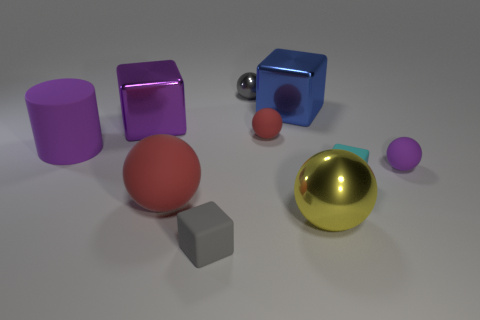How many small matte cubes are the same color as the large metallic sphere?
Give a very brief answer. 0. What is the large thing that is right of the small red rubber ball and in front of the large rubber cylinder made of?
Provide a short and direct response. Metal. Do the block on the left side of the tiny gray block and the big rubber object that is to the left of the large red matte object have the same color?
Offer a very short reply. Yes. What number of red things are tiny blocks or big rubber cubes?
Offer a very short reply. 0. Are there fewer large purple objects that are behind the cylinder than red matte balls behind the tiny gray rubber block?
Provide a succinct answer. Yes. Is there a gray matte object of the same size as the yellow thing?
Your answer should be compact. No. There is a purple rubber thing that is to the right of the purple shiny thing; is its size the same as the small red object?
Keep it short and to the point. Yes. Are there more red balls than tiny red rubber things?
Offer a very short reply. Yes. Are there any other small shiny things that have the same shape as the tiny red thing?
Your answer should be compact. Yes. There is a purple object that is to the right of the large yellow object; what is its shape?
Provide a succinct answer. Sphere. 